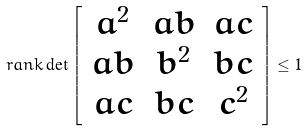<formula> <loc_0><loc_0><loc_500><loc_500>\ r a n k \det \left [ \begin{array} { c c c } a ^ { 2 } & a b & a c \\ a b & b ^ { 2 } & b c \\ a c & b c & c ^ { 2 } \end{array} \right ] \leq 1</formula> 